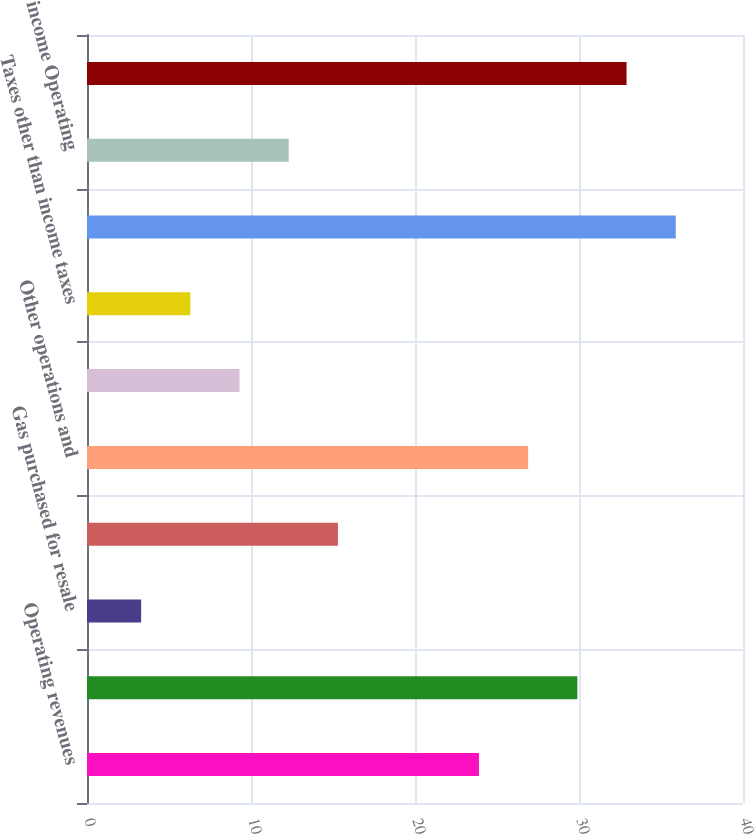<chart> <loc_0><loc_0><loc_500><loc_500><bar_chart><fcel>Operating revenues<fcel>power Purchased<fcel>Gas purchased for resale<fcel>Operating revenues less<fcel>Other operations and<fcel>Depreciation and amortization<fcel>Taxes other than income taxes<fcel>taxes Income<fcel>income Operating<fcel>expense interest Net<nl><fcel>23.9<fcel>29.9<fcel>3.3<fcel>15.3<fcel>26.9<fcel>9.3<fcel>6.3<fcel>35.9<fcel>12.3<fcel>32.9<nl></chart> 